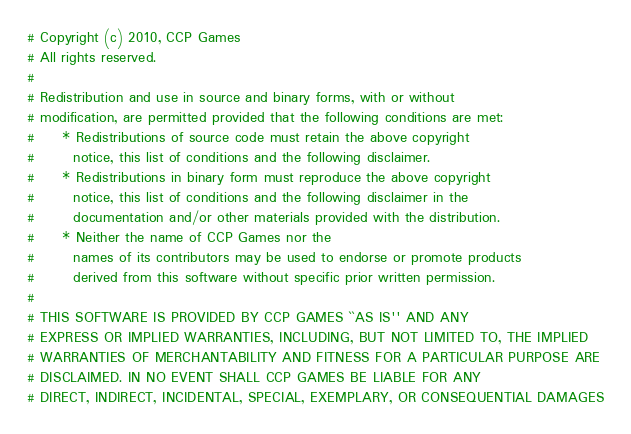Convert code to text. <code><loc_0><loc_0><loc_500><loc_500><_Python_># Copyright (c) 2010, CCP Games
# All rights reserved.
#
# Redistribution and use in source and binary forms, with or without
# modification, are permitted provided that the following conditions are met:
#     * Redistributions of source code must retain the above copyright
#       notice, this list of conditions and the following disclaimer.
#     * Redistributions in binary form must reproduce the above copyright
#       notice, this list of conditions and the following disclaimer in the
#       documentation and/or other materials provided with the distribution.
#     * Neither the name of CCP Games nor the
#       names of its contributors may be used to endorse or promote products
#       derived from this software without specific prior written permission.
#
# THIS SOFTWARE IS PROVIDED BY CCP GAMES ``AS IS'' AND ANY
# EXPRESS OR IMPLIED WARRANTIES, INCLUDING, BUT NOT LIMITED TO, THE IMPLIED
# WARRANTIES OF MERCHANTABILITY AND FITNESS FOR A PARTICULAR PURPOSE ARE
# DISCLAIMED. IN NO EVENT SHALL CCP GAMES BE LIABLE FOR ANY
# DIRECT, INDIRECT, INCIDENTAL, SPECIAL, EXEMPLARY, OR CONSEQUENTIAL DAMAGES</code> 